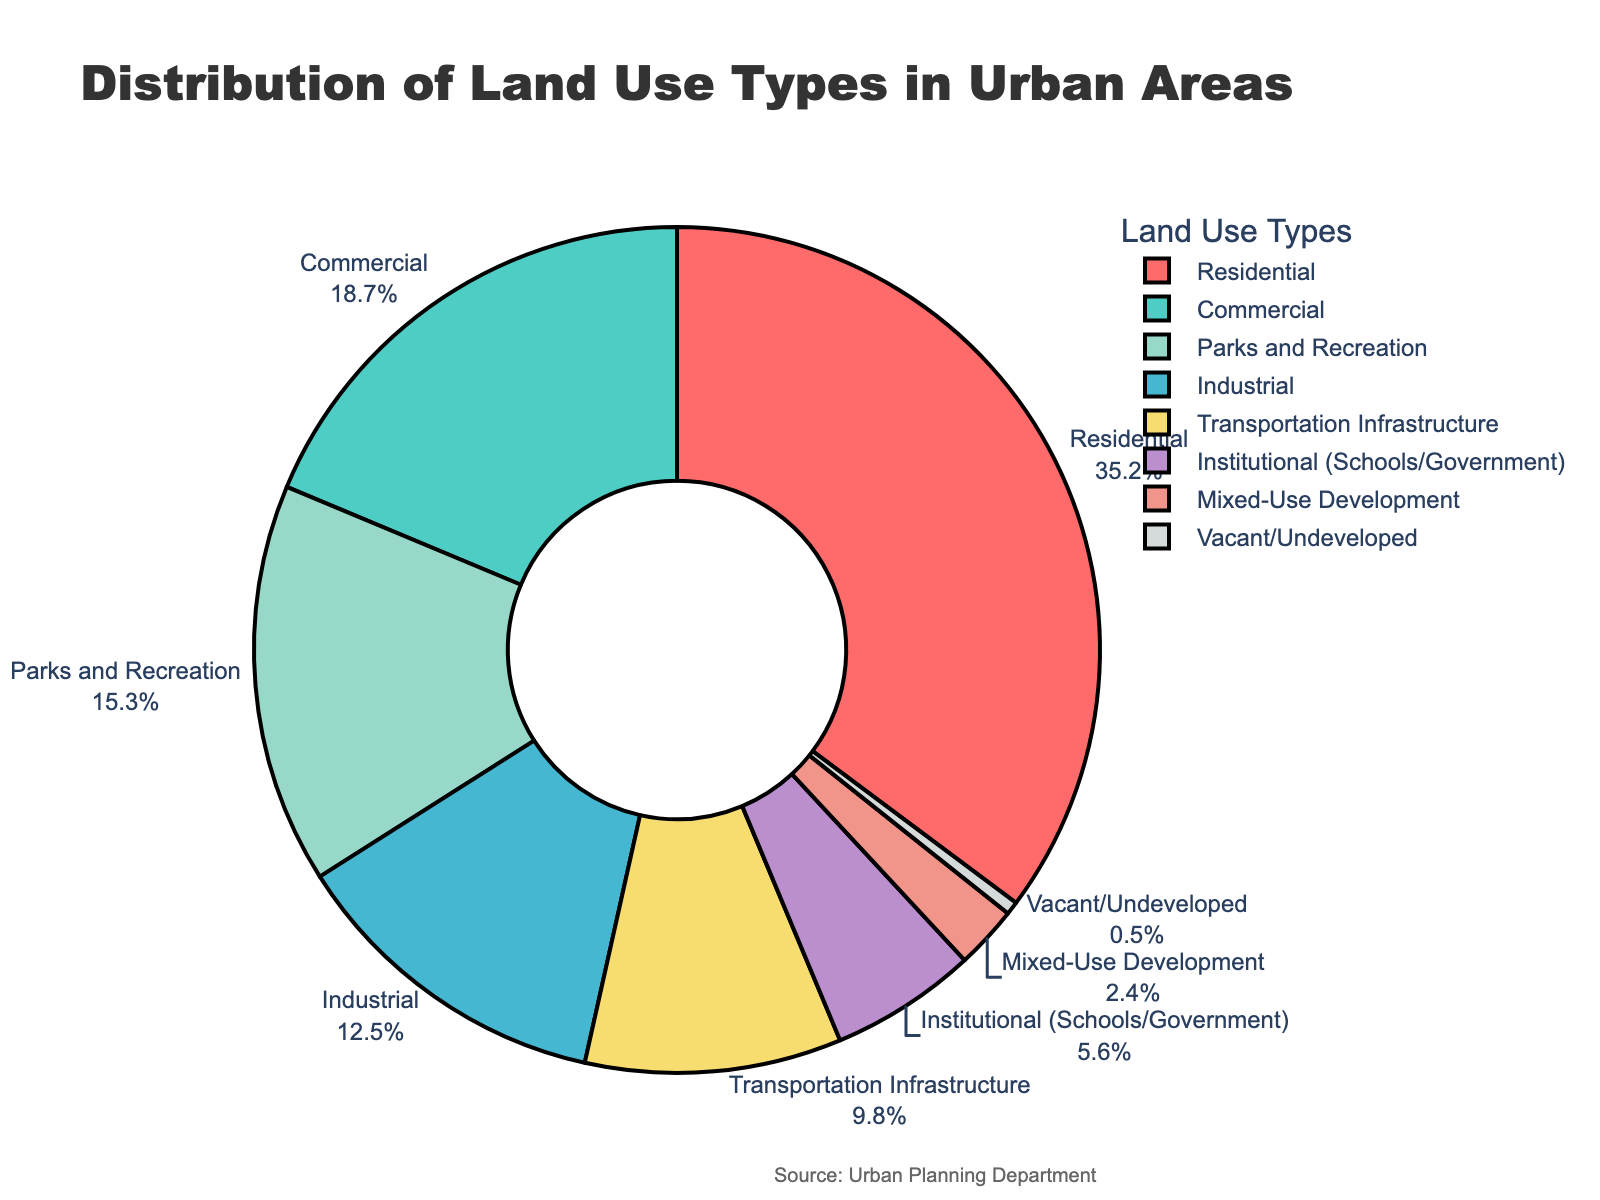What is the largest land use type in urban areas? To determine the largest land use type, refer to the percentages in the figure. The largest percentage is 35.2%, which corresponds to Residential.
Answer: Residential Which land use type has the smallest percentage? The smallest percentage visible in the pie chart is 0.5%, which corresponds to Vacant/Undeveloped.
Answer: Vacant/Undeveloped What is the combined percentage of Parks and Recreation and Institutional land use types? Add the percentages of Parks and Recreation (15.3%) and Institutional (5.6%). 15.3 + 5.6 = 20.9%
Answer: 20.9% How much larger is the Residential land use type compared to the Commercial land use type? Subtract the Commercial percentage (18.7%) from the Residential percentage (35.2%). 35.2 - 18.7 = 16.5%
Answer: 16.5% Which land use type occupies more space: Parks and Recreation or Industrial? Compare the percentages of Parks and Recreation (15.3%) and Industrial (12.5%). Parks and Recreation has a higher percentage.
Answer: Parks and Recreation What percentage of the urban area is used for Transportation Infrastructure? Referring to the pie chart, the Transportation Infrastructure occupies 9.8% of the urban area.
Answer: 9.8% Which land use types are represented by the red and green sections of the pie chart? The pie chart shows the Residential section in red and the Commercial section in green.
Answer: Residential (red), Commercial (green) What is the difference in percentage between Mixed-Use Development and Vacant/Undeveloped land use types? Subtract the percentage of Vacant/Undeveloped (0.5%) from Mixed-Use Development (2.4%). 2.4 - 0.5 = 1.9%
Answer: 1.9% How does the percentage of Commercial land use compare to the sum of Institutional and Transportation Infrastructure land use percentages? First sum the percentages of Institutional (5.6%) and Transportation Infrastructure (9.8%), which is 5.6 + 9.8 = 15.4%. Compare this to Commercial (18.7%). The Commercial percentage is larger.
Answer: Commercial is larger by 3.3% 